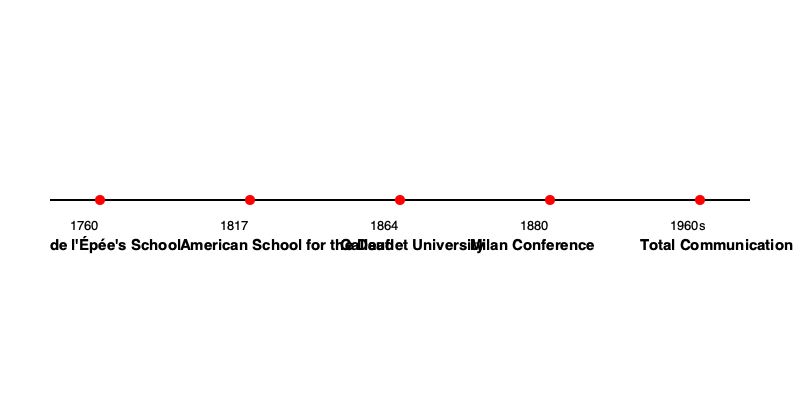Based on the timeline, which event marked a significant setback in sign language education, and how did the approach to deaf education evolve in the following century? 1. The timeline shows key events in the historical development of sign language education.

2. The 1880 Milan Conference is a crucial point on the timeline. This event marked a significant setback in sign language education.

3. At the Milan Conference, a resolution was passed that declared oral education (speech and lip-reading) superior to manual education (sign language). This led to the widespread adoption of oralism in deaf education.

4. For nearly a century following the Milan Conference, many deaf schools banned the use of sign language, focusing instead on speech therapy and lip-reading.

5. However, the timeline shows that in the 1960s, a new approach called Total Communication emerged.

6. Total Communication is an educational approach that combines various methods of communication, including sign language, speech, lip-reading, and writing. This marked a shift back towards the inclusion of sign language in deaf education.

7. The evolution from the oralism imposed by the Milan Conference to the Total Communication approach of the 1960s represents a significant change in deaf education philosophy over the course of about 80 years.
Answer: The 1880 Milan Conference; evolved from oralism to Total Communication by the 1960s. 